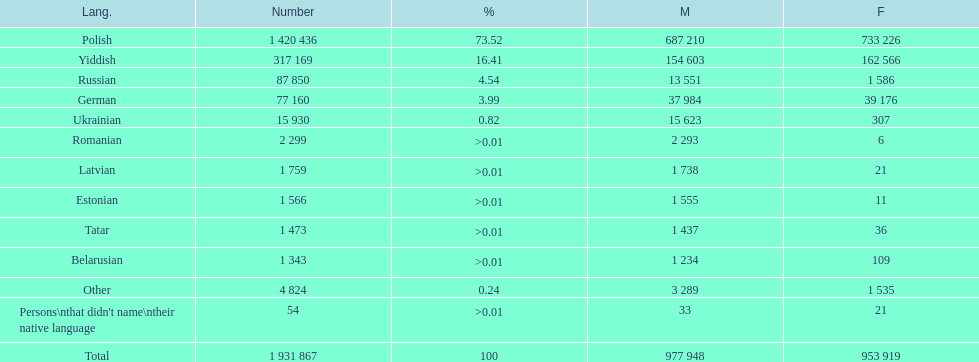What is the largest proportion of non-polish speakers? Yiddish. 